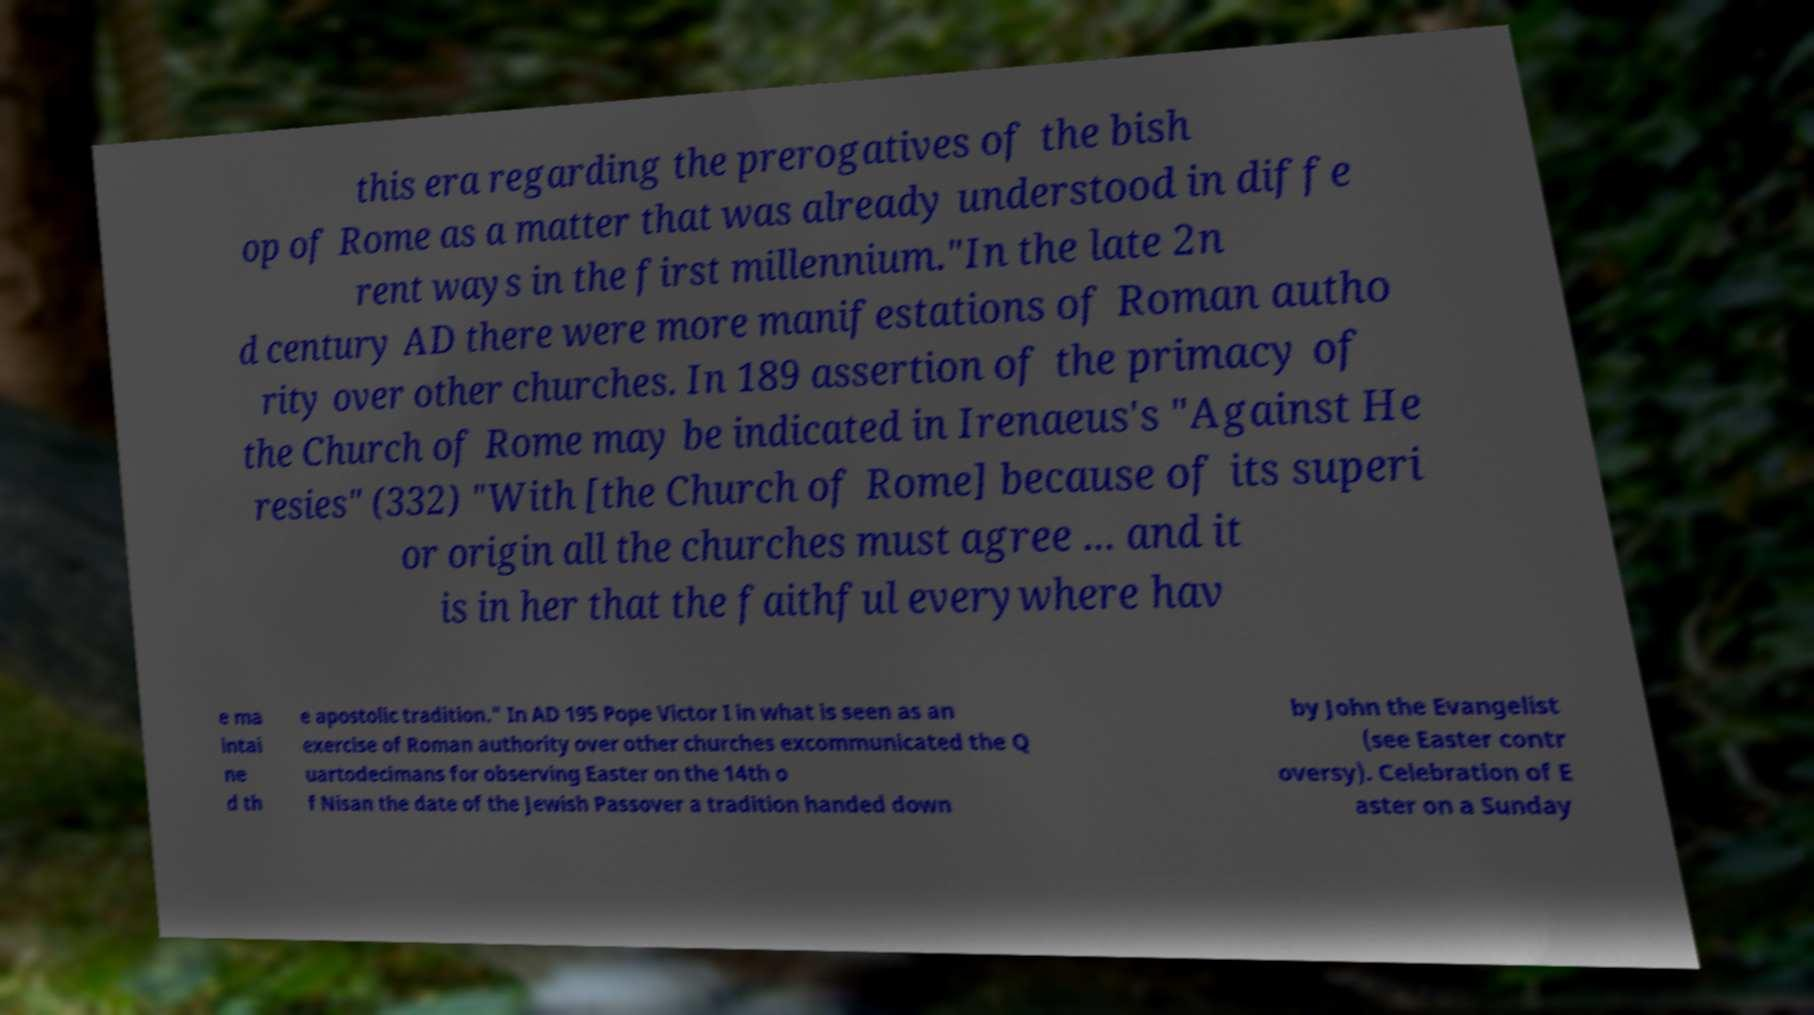Could you assist in decoding the text presented in this image and type it out clearly? this era regarding the prerogatives of the bish op of Rome as a matter that was already understood in diffe rent ways in the first millennium."In the late 2n d century AD there were more manifestations of Roman autho rity over other churches. In 189 assertion of the primacy of the Church of Rome may be indicated in Irenaeus's "Against He resies" (332) "With [the Church of Rome] because of its superi or origin all the churches must agree ... and it is in her that the faithful everywhere hav e ma intai ne d th e apostolic tradition." In AD 195 Pope Victor I in what is seen as an exercise of Roman authority over other churches excommunicated the Q uartodecimans for observing Easter on the 14th o f Nisan the date of the Jewish Passover a tradition handed down by John the Evangelist (see Easter contr oversy). Celebration of E aster on a Sunday 